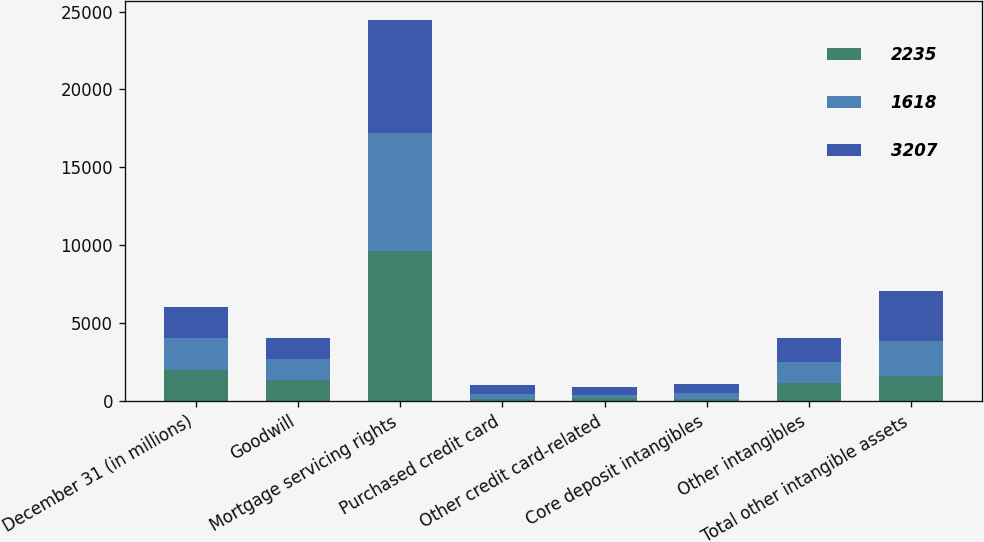Convert chart to OTSL. <chart><loc_0><loc_0><loc_500><loc_500><stacked_bar_chart><ecel><fcel>December 31 (in millions)<fcel>Goodwill<fcel>Mortgage servicing rights<fcel>Purchased credit card<fcel>Other credit card-related<fcel>Core deposit intangibles<fcel>Other intangibles<fcel>Total other intangible assets<nl><fcel>2235<fcel>2013<fcel>1356<fcel>9614<fcel>131<fcel>173<fcel>159<fcel>1155<fcel>1618<nl><fcel>1618<fcel>2012<fcel>1356<fcel>7614<fcel>295<fcel>229<fcel>355<fcel>1356<fcel>2235<nl><fcel>3207<fcel>2011<fcel>1356<fcel>7223<fcel>602<fcel>488<fcel>594<fcel>1523<fcel>3207<nl></chart> 